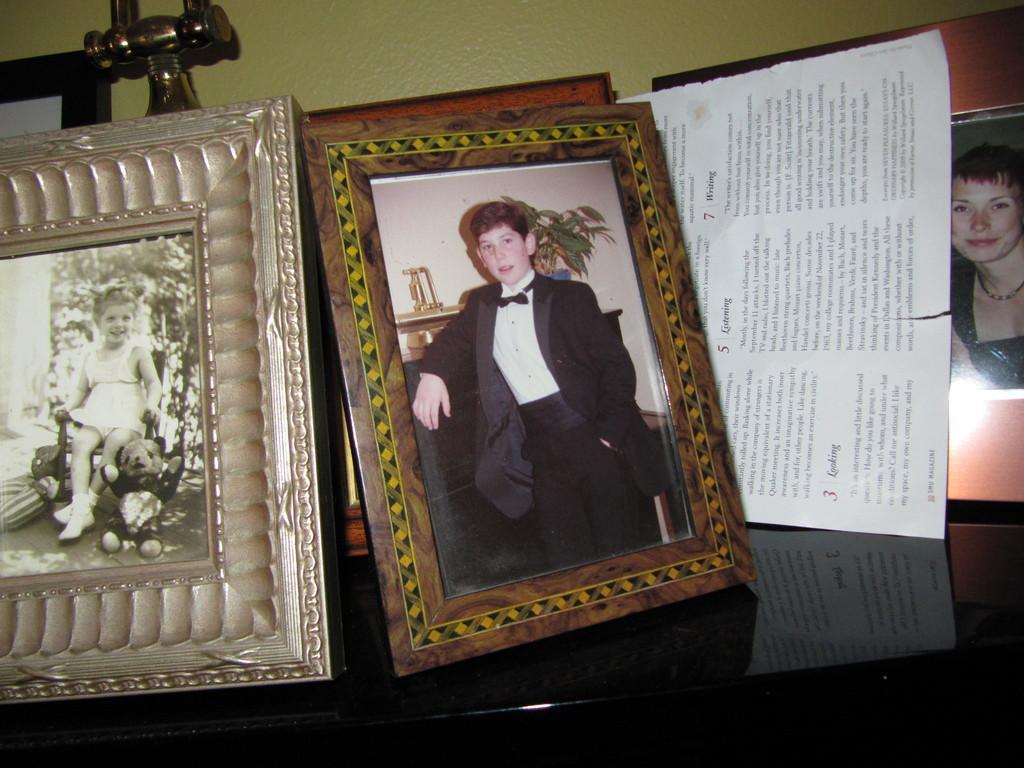Can you describe this image briefly? In this image I see the photo frames on this black color surface and I see a paper over here on which there are words and numbers on it and I see that it is torn a bit and I see the yellow color wall and I see a golden color thing over here. 